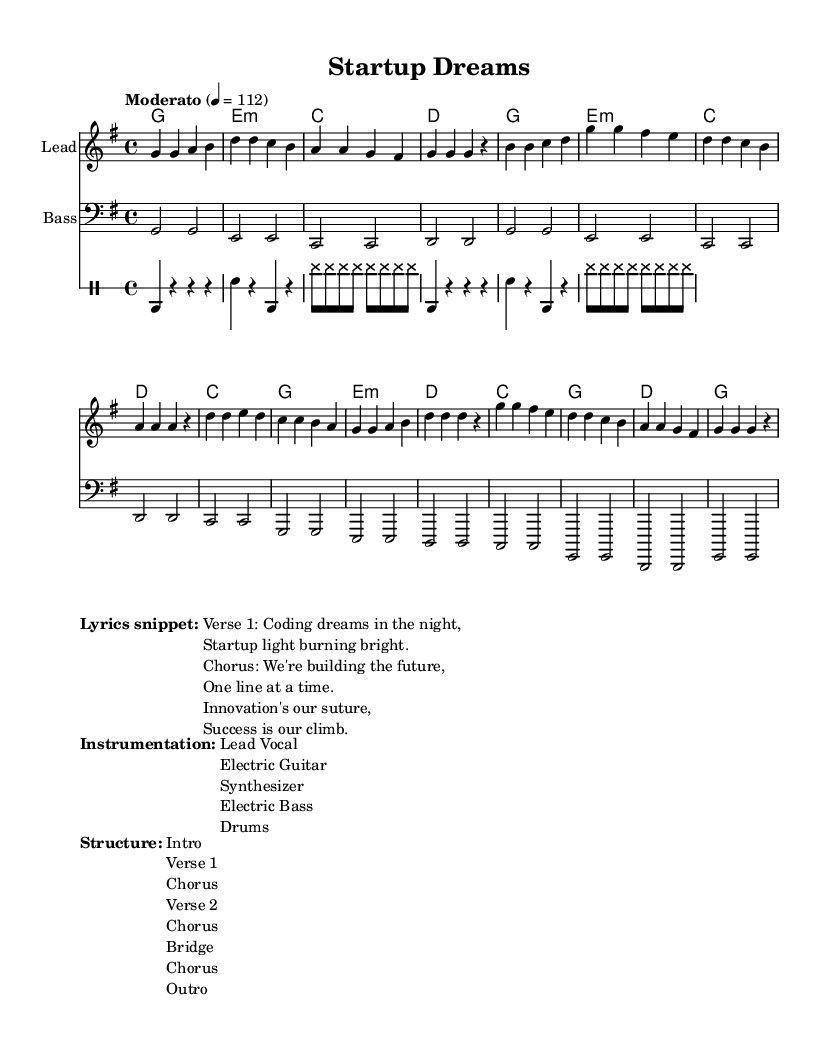What is the key signature of this music? The key signature is G major, which has one sharp (F#). This can be identified at the beginning of the staff, where the sharp symbol appears.
Answer: G major What is the time signature of the piece? The time signature is 4/4, meaning there are four beats in each measure and a quarter note gets one beat. This is indicated at the beginning of the score with the "4/4" notation.
Answer: 4/4 What is the tempo marking for this music? The tempo marking is "Moderato," with a metronome marking of 112 beats per minute. This indicates a moderate pace for the performance.
Answer: Moderato, 112 How many sections are there in the structure of the song? The structure lists an intro, two verses, a bridge, and three choruses, which sums up to seven sections in total. This can be counted directly from the structure section of the sheet music.
Answer: 7 What is the primary theme expressed in the lyrics? The primary theme expressed in the lyrics revolves around coding, innovation, and entrepreneurial aspirations. This can be inferred from the words "coding dreams," "building the future," and "innovation's our suture."
Answer: Entrepreneurship What instruments are included in the instrumentation? The instrumentation includes lead vocal, electric guitar, synthesizer, electric bass, and drums. This information is provided in the instrumentation section of the score.
Answer: Lead Vocal, Electric Guitar, Synthesizer, Electric Bass, Drums What type of chord is primarily used in the harmonies? The primary chord used in the harmonies is G major, which is found prominently at the beginning of the chord chart. This establishes the tonality of the piece.
Answer: G major 